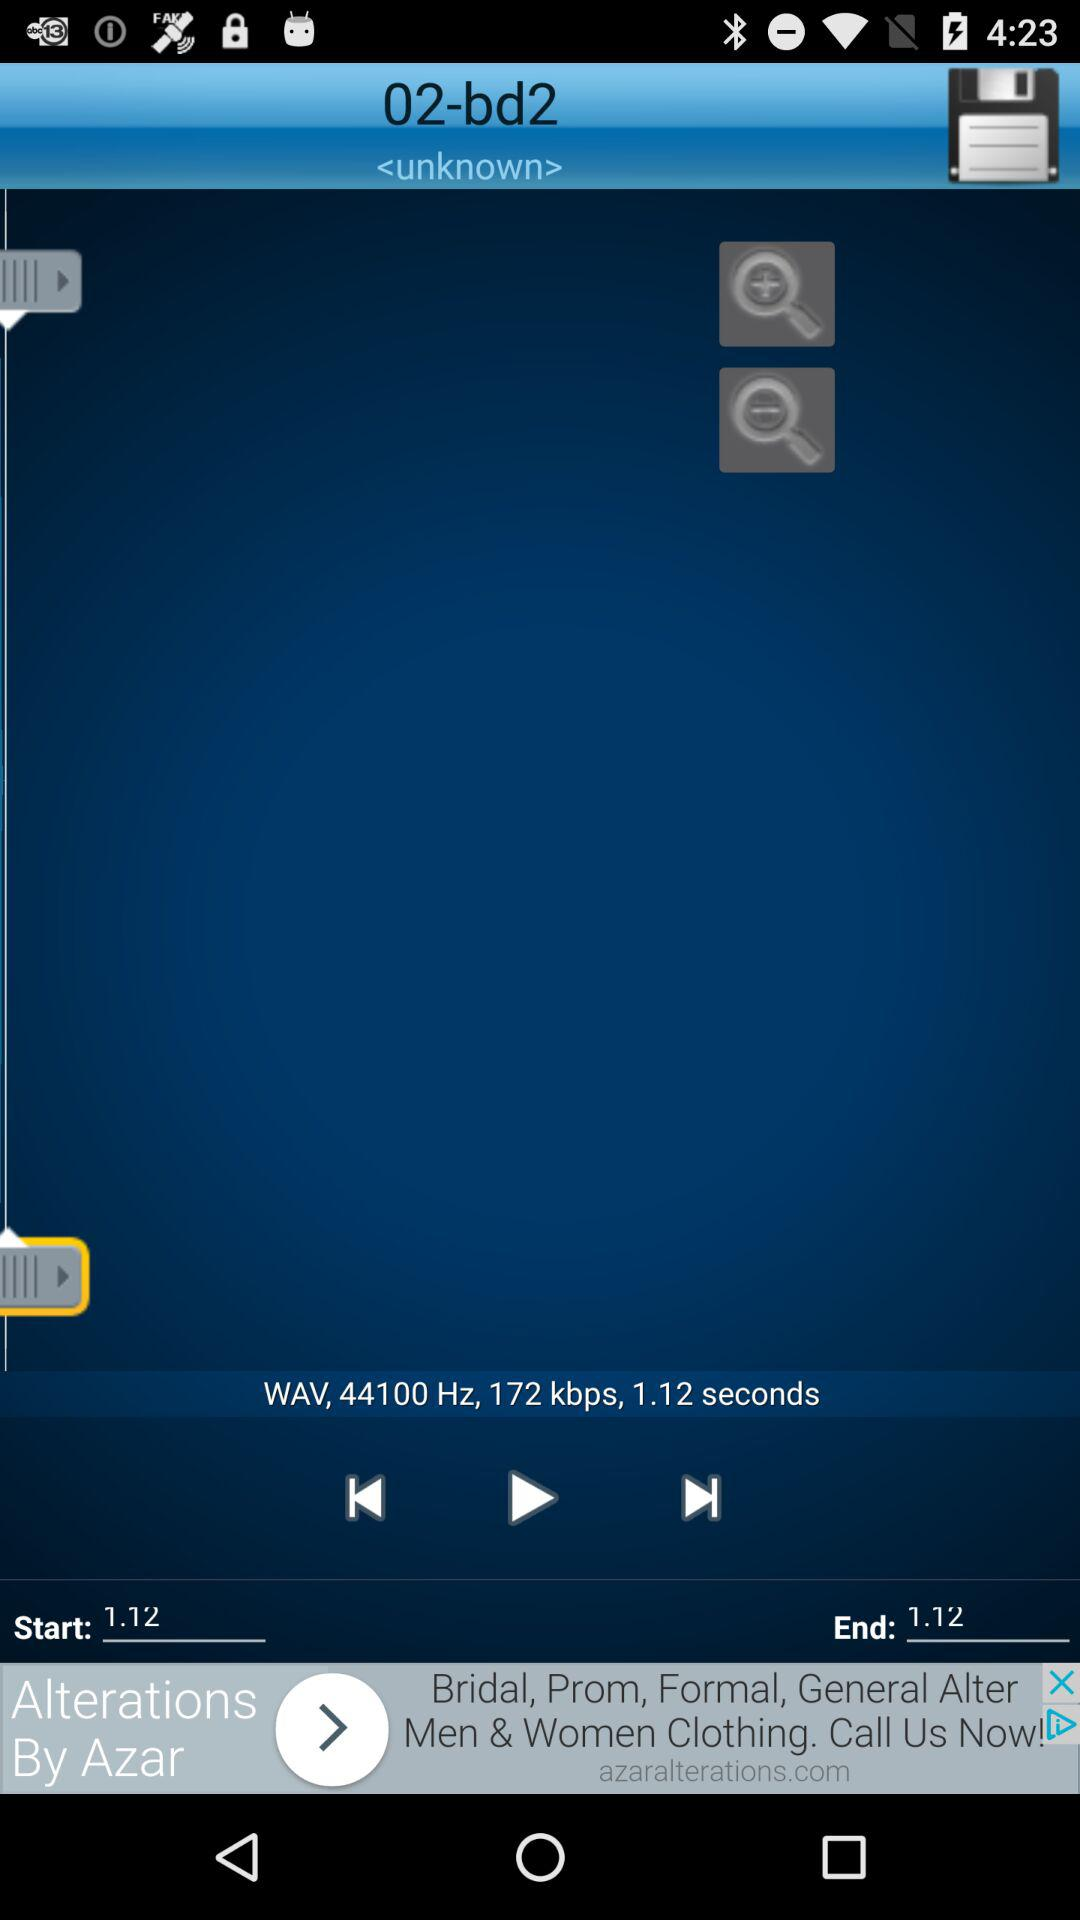What is the music's speed? The music's speed is 172 kbps. 